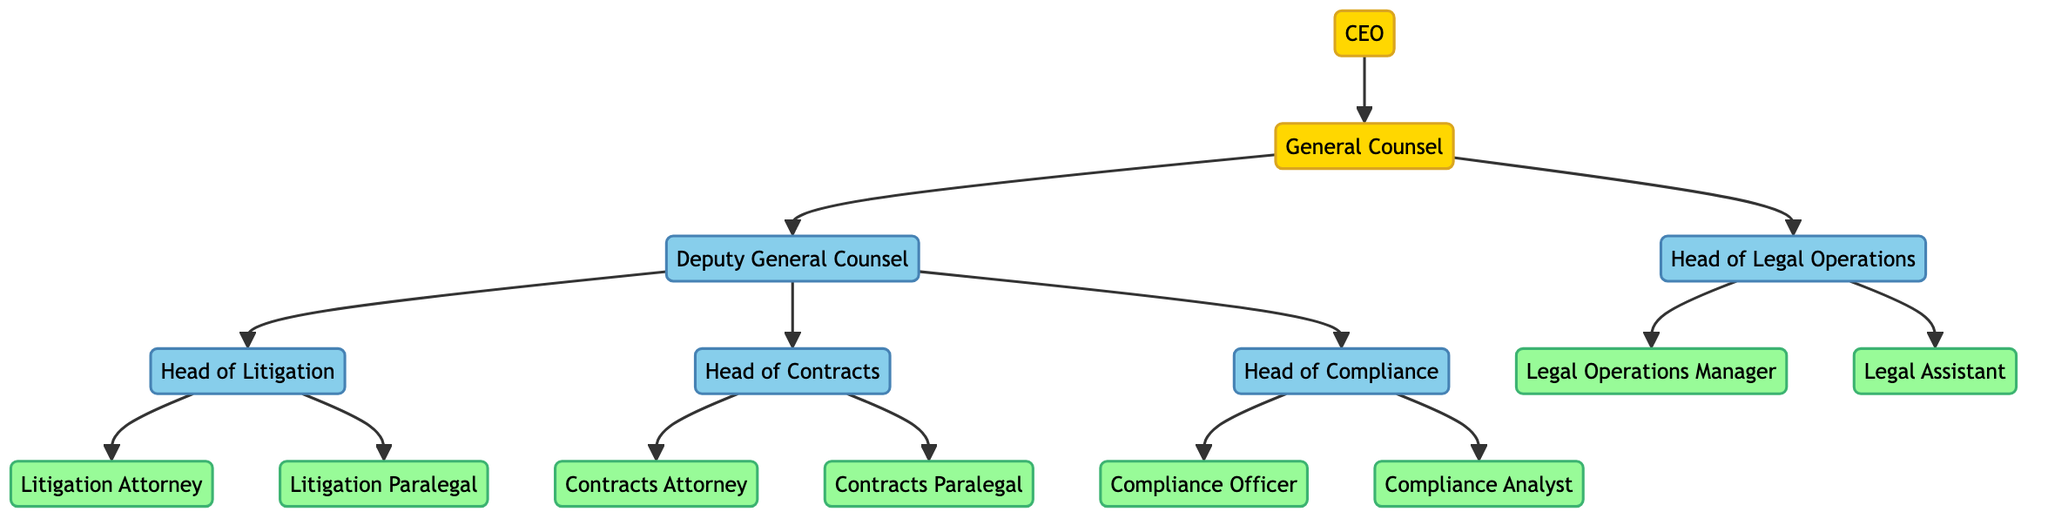What is the title of the person who oversees all legal matters? The title shown in the diagram for the person overseeing all legal matters is "General Counsel," which is directly connected to the CEO as their role.
Answer: General Counsel How many heads report directly to the General Counsel? Examining the diagram, there are two heads directly reporting to the General Counsel, which are the Deputy General Counsel and the Head of Legal Operations.
Answer: 2 Who is responsible for overseeing lawsuits? The Head of Litigation, which is listed as a subordinate under the Deputy General Counsel, is responsible for overseeing lawsuits according to the relationships in the diagram.
Answer: Head of Litigation Which department is responsible for ensuring regulatory compliance? The Compliance Department, headed by the Head of Compliance, is designated in the diagram to ensure regulatory compliance as per the structure depicted.
Answer: Compliance What roles do the Contracts Attorney and the Contracts Paralegal fulfill? The Contracts Attorney is responsible for drafting and reviewing contracts as well as negotiating terms, while the Contracts Paralegal supports the attorney and handles document management and research, as detailed in their respective nodes.
Answer: Drafting and reviewing contracts; supports and handles document management What is the relationship between the Deputy General Counsel and the Litigation Head? The Deputy General Counsel directly supervises the Litigation Head, indicating a managerial relationship where the Deputy General Counsel oversees the operations of that specific legal department as illustrated in the diagram.
Answer: Supervises How many total legal operations support roles are shown in the diagram? The Legal Operations section of the diagram lists two roles: the Legal Operations Manager and the Legal Assistant, indicating there are two support roles in this department.
Answer: 2 Which role focuses on developing compliance policies? The Compliance Officer is the role indicated in the diagram as being responsible for developing compliance policies, which is part of their main responsibilities under the Head of Compliance.
Answer: Compliance Officer What kind of tasks does the Legal Assistant perform? The diagram shows that the Legal Assistant handles administrative tasks, document management, and scheduling - summarizing the diverse functions involved in supporting the legal department’s operations.
Answer: Administrative tasks, document management, scheduling 